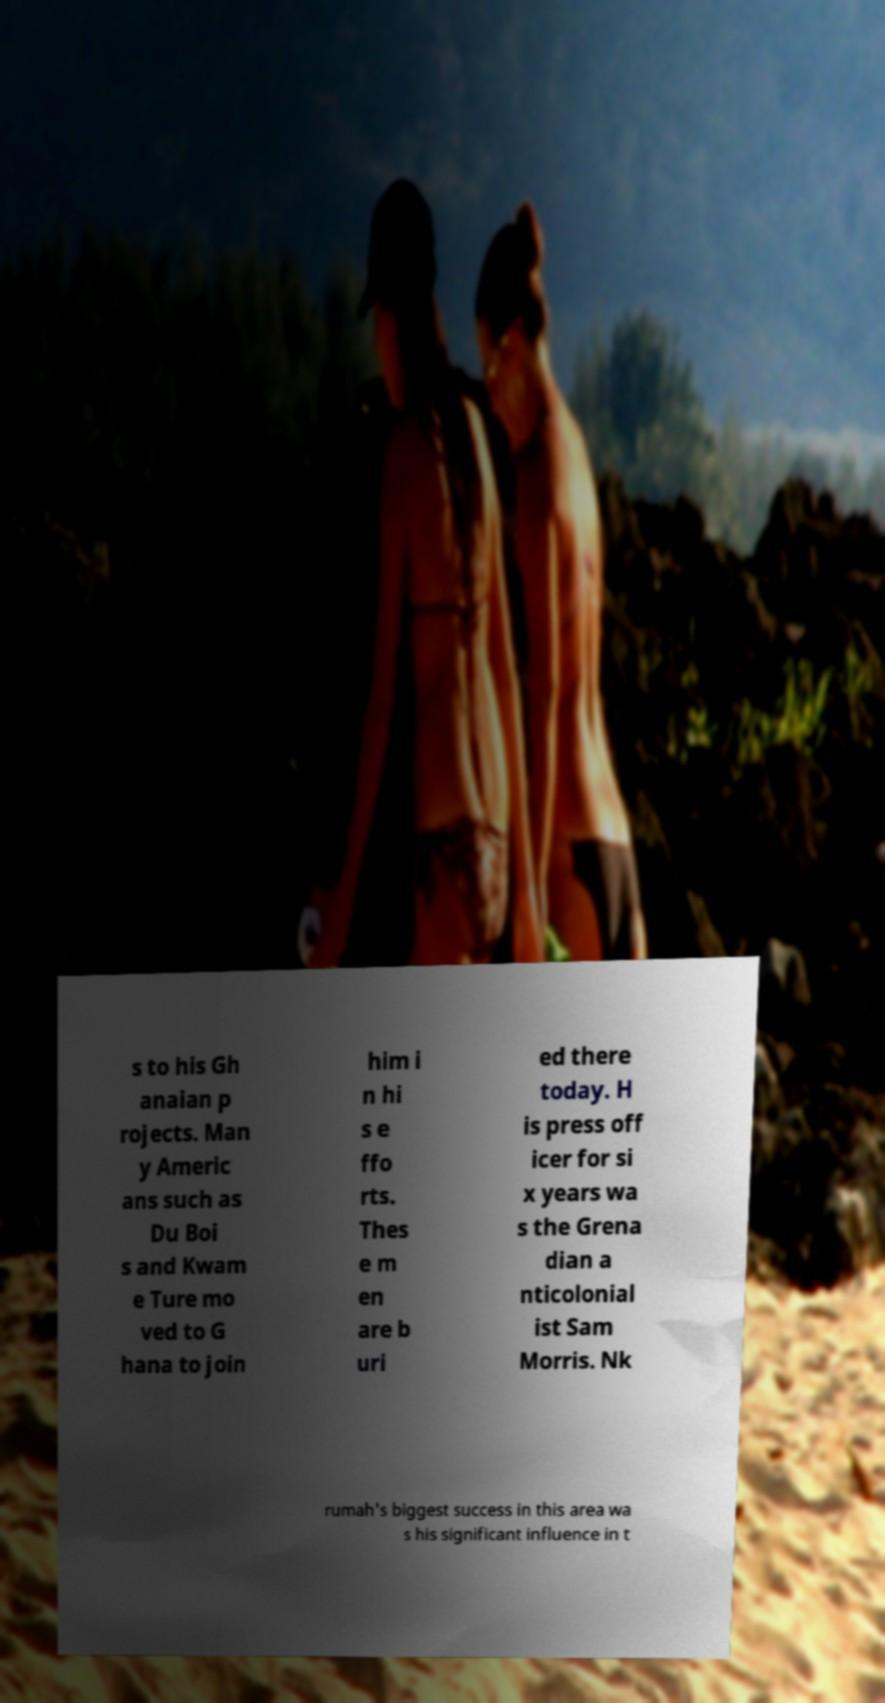Can you accurately transcribe the text from the provided image for me? s to his Gh anaian p rojects. Man y Americ ans such as Du Boi s and Kwam e Ture mo ved to G hana to join him i n hi s e ffo rts. Thes e m en are b uri ed there today. H is press off icer for si x years wa s the Grena dian a nticolonial ist Sam Morris. Nk rumah's biggest success in this area wa s his significant influence in t 